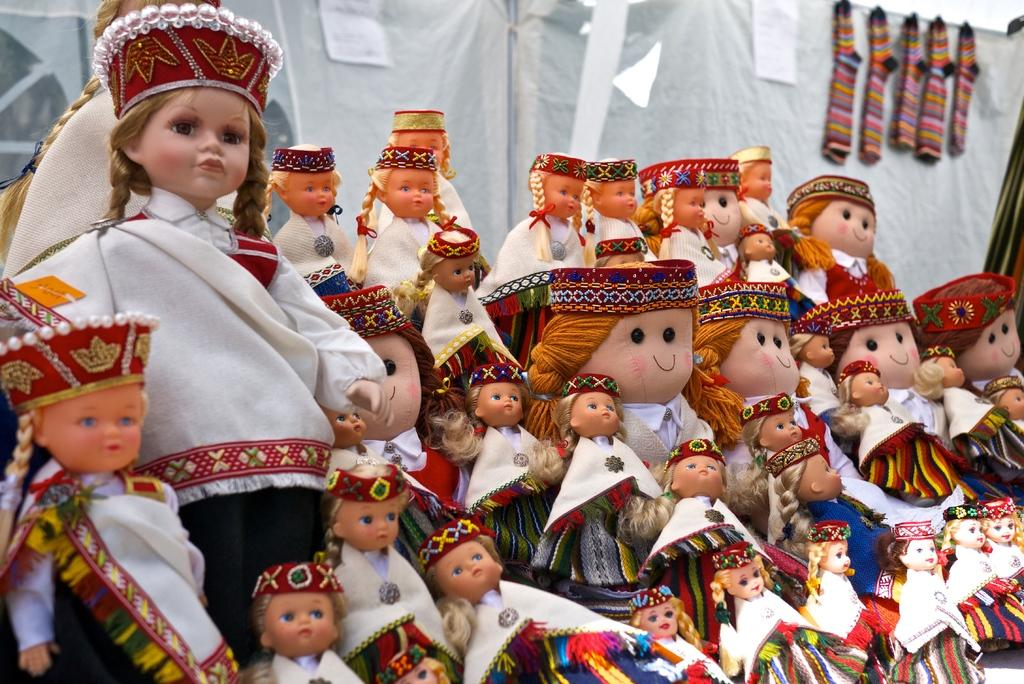What is the main subject of the image? There are many dolls in the image. How are the dolls dressed? The dolls are beautifully dressed. What can be seen in the background of the image? There is a white cloth in the background of the image. What direction is the duck facing in the image? There is no duck present in the image. How does the sand feel in the image? There is no sand present in the image. 